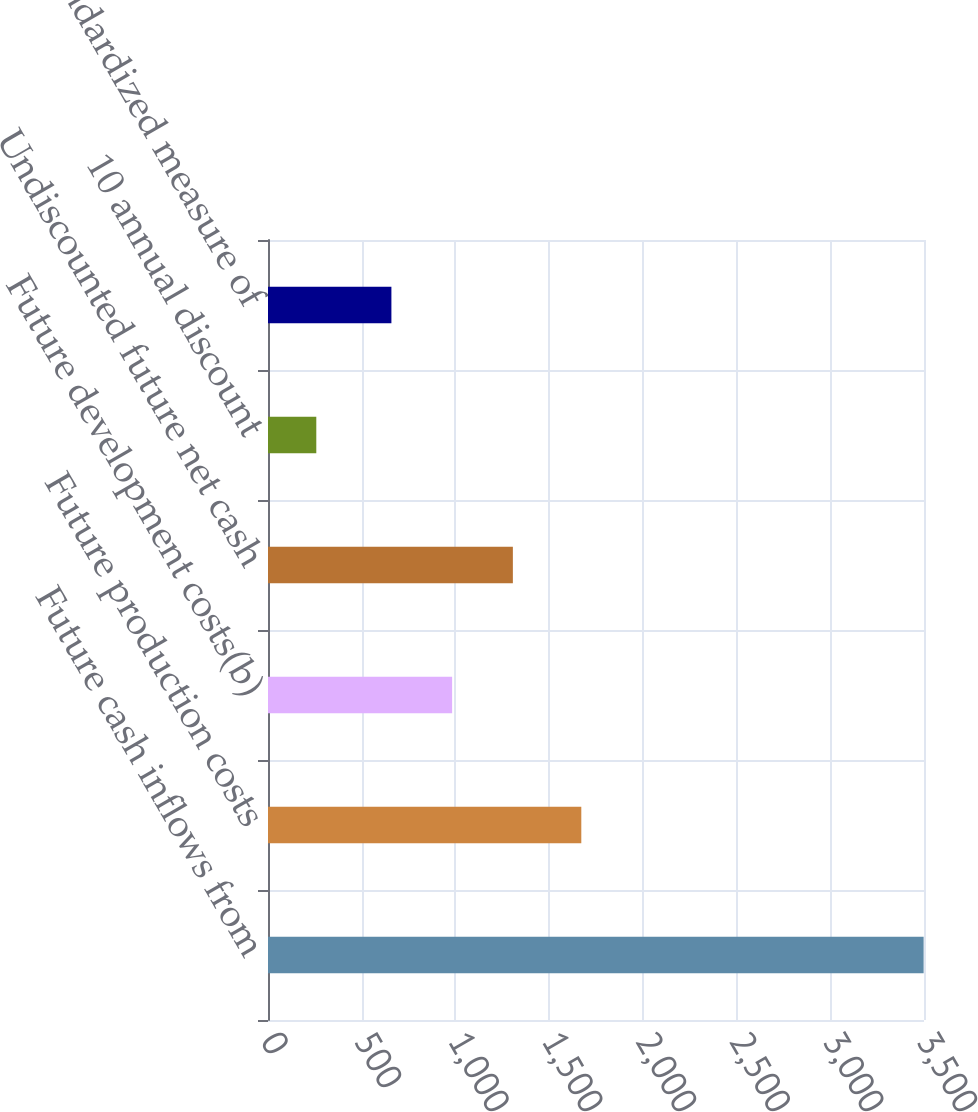<chart> <loc_0><loc_0><loc_500><loc_500><bar_chart><fcel>Future cash inflows from<fcel>Future production costs<fcel>Future development costs(b)<fcel>Undiscounted future net cash<fcel>10 annual discount<fcel>Standardized measure of<nl><fcel>3498<fcel>1671.6<fcel>982.43<fcel>1306.46<fcel>257.7<fcel>658.4<nl></chart> 